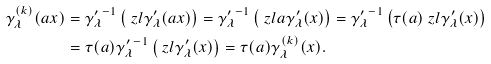Convert formula to latex. <formula><loc_0><loc_0><loc_500><loc_500>\gamma _ { \lambda } ^ { ( k ) } ( a x ) & = { \gamma ^ { \prime } _ { \lambda } } ^ { - 1 } \left ( \ z l \gamma _ { \lambda } ^ { \prime } ( a x ) \right ) = { \gamma ^ { \prime } _ { \lambda } } ^ { - 1 } \left ( \ z l a \gamma ^ { \prime } _ { \lambda } ( x ) \right ) = { \gamma ^ { \prime } _ { \lambda } } ^ { - 1 } \left ( \tau ( a ) \ z l \gamma ^ { \prime } _ { \lambda } ( x ) \right ) \\ & = \tau ( a ) { \gamma ^ { \prime } _ { \lambda } } ^ { - 1 } \left ( \ z l \gamma ^ { \prime } _ { \lambda } ( x ) \right ) = \tau ( a ) \gamma _ { \lambda } ^ { ( k ) } ( x ) .</formula> 